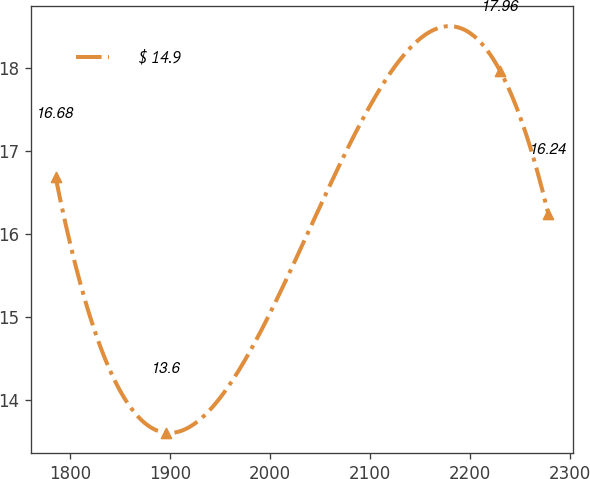Convert chart to OTSL. <chart><loc_0><loc_0><loc_500><loc_500><line_chart><ecel><fcel>$ 14.9<nl><fcel>1785.57<fcel>16.68<nl><fcel>1896.1<fcel>13.6<nl><fcel>2230.58<fcel>17.96<nl><fcel>2278.72<fcel>16.24<nl></chart> 